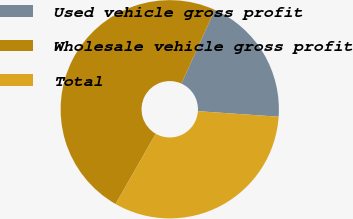<chart> <loc_0><loc_0><loc_500><loc_500><pie_chart><fcel>Used vehicle gross profit<fcel>Wholesale vehicle gross profit<fcel>Total<nl><fcel>19.31%<fcel>48.51%<fcel>32.18%<nl></chart> 